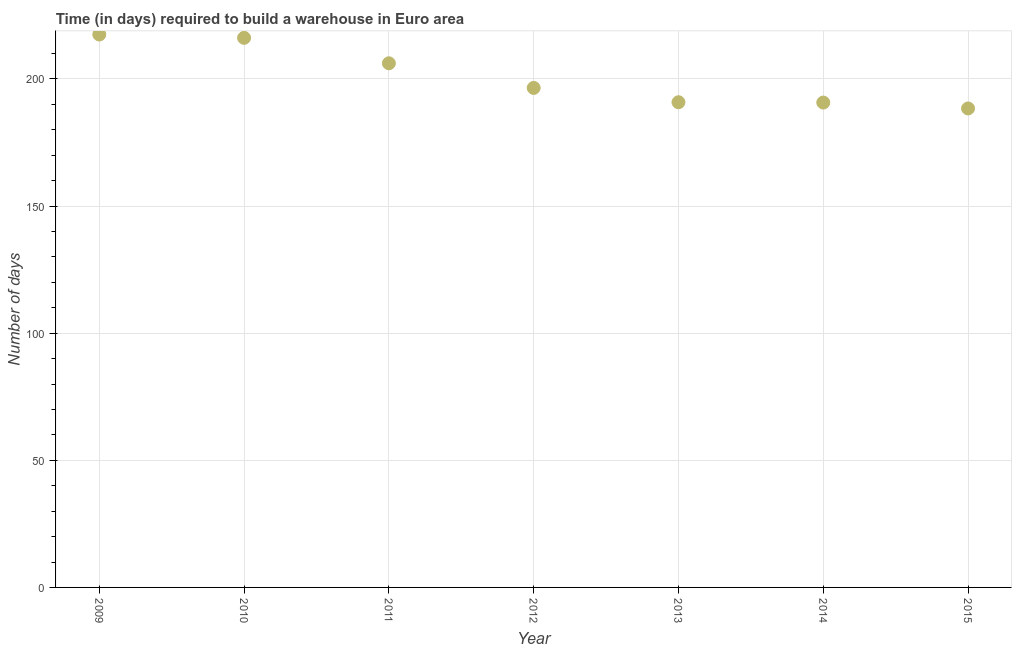What is the time required to build a warehouse in 2010?
Provide a succinct answer. 216.17. Across all years, what is the maximum time required to build a warehouse?
Make the answer very short. 217.47. Across all years, what is the minimum time required to build a warehouse?
Your answer should be compact. 188.39. In which year was the time required to build a warehouse maximum?
Provide a short and direct response. 2009. In which year was the time required to build a warehouse minimum?
Your answer should be compact. 2015. What is the sum of the time required to build a warehouse?
Offer a terse response. 1406.22. What is the difference between the time required to build a warehouse in 2009 and 2011?
Provide a succinct answer. 11.31. What is the average time required to build a warehouse per year?
Offer a terse response. 200.89. What is the median time required to build a warehouse?
Offer a terse response. 196.47. In how many years, is the time required to build a warehouse greater than 70 days?
Your answer should be compact. 7. What is the ratio of the time required to build a warehouse in 2009 to that in 2012?
Offer a very short reply. 1.11. Is the time required to build a warehouse in 2010 less than that in 2014?
Offer a very short reply. No. Is the difference between the time required to build a warehouse in 2011 and 2014 greater than the difference between any two years?
Offer a terse response. No. What is the difference between the highest and the second highest time required to build a warehouse?
Keep it short and to the point. 1.31. Is the sum of the time required to build a warehouse in 2013 and 2015 greater than the maximum time required to build a warehouse across all years?
Provide a short and direct response. Yes. What is the difference between the highest and the lowest time required to build a warehouse?
Offer a very short reply. 29.08. In how many years, is the time required to build a warehouse greater than the average time required to build a warehouse taken over all years?
Your answer should be compact. 3. How many dotlines are there?
Your response must be concise. 1. What is the difference between two consecutive major ticks on the Y-axis?
Your answer should be compact. 50. Are the values on the major ticks of Y-axis written in scientific E-notation?
Offer a terse response. No. Does the graph contain grids?
Make the answer very short. Yes. What is the title of the graph?
Provide a short and direct response. Time (in days) required to build a warehouse in Euro area. What is the label or title of the X-axis?
Provide a short and direct response. Year. What is the label or title of the Y-axis?
Your answer should be compact. Number of days. What is the Number of days in 2009?
Keep it short and to the point. 217.47. What is the Number of days in 2010?
Ensure brevity in your answer.  216.17. What is the Number of days in 2011?
Your response must be concise. 206.16. What is the Number of days in 2012?
Provide a succinct answer. 196.47. What is the Number of days in 2013?
Your answer should be very brief. 190.84. What is the Number of days in 2014?
Your answer should be very brief. 190.71. What is the Number of days in 2015?
Provide a succinct answer. 188.39. What is the difference between the Number of days in 2009 and 2010?
Your response must be concise. 1.31. What is the difference between the Number of days in 2009 and 2011?
Offer a very short reply. 11.31. What is the difference between the Number of days in 2009 and 2012?
Your answer should be compact. 21. What is the difference between the Number of days in 2009 and 2013?
Ensure brevity in your answer.  26.63. What is the difference between the Number of days in 2009 and 2014?
Make the answer very short. 26.76. What is the difference between the Number of days in 2009 and 2015?
Provide a short and direct response. 29.08. What is the difference between the Number of days in 2010 and 2011?
Offer a terse response. 10.01. What is the difference between the Number of days in 2010 and 2012?
Your response must be concise. 19.69. What is the difference between the Number of days in 2010 and 2013?
Provide a short and direct response. 25.32. What is the difference between the Number of days in 2010 and 2014?
Give a very brief answer. 25.46. What is the difference between the Number of days in 2010 and 2015?
Ensure brevity in your answer.  27.77. What is the difference between the Number of days in 2011 and 2012?
Offer a very short reply. 9.68. What is the difference between the Number of days in 2011 and 2013?
Your response must be concise. 15.32. What is the difference between the Number of days in 2011 and 2014?
Ensure brevity in your answer.  15.45. What is the difference between the Number of days in 2011 and 2015?
Your answer should be very brief. 17.76. What is the difference between the Number of days in 2012 and 2013?
Your answer should be compact. 5.63. What is the difference between the Number of days in 2012 and 2014?
Offer a terse response. 5.76. What is the difference between the Number of days in 2012 and 2015?
Your answer should be very brief. 8.08. What is the difference between the Number of days in 2013 and 2014?
Provide a succinct answer. 0.13. What is the difference between the Number of days in 2013 and 2015?
Provide a short and direct response. 2.45. What is the difference between the Number of days in 2014 and 2015?
Ensure brevity in your answer.  2.32. What is the ratio of the Number of days in 2009 to that in 2011?
Offer a very short reply. 1.05. What is the ratio of the Number of days in 2009 to that in 2012?
Give a very brief answer. 1.11. What is the ratio of the Number of days in 2009 to that in 2013?
Offer a very short reply. 1.14. What is the ratio of the Number of days in 2009 to that in 2014?
Offer a terse response. 1.14. What is the ratio of the Number of days in 2009 to that in 2015?
Offer a very short reply. 1.15. What is the ratio of the Number of days in 2010 to that in 2011?
Make the answer very short. 1.05. What is the ratio of the Number of days in 2010 to that in 2013?
Make the answer very short. 1.13. What is the ratio of the Number of days in 2010 to that in 2014?
Your answer should be very brief. 1.13. What is the ratio of the Number of days in 2010 to that in 2015?
Your answer should be very brief. 1.15. What is the ratio of the Number of days in 2011 to that in 2012?
Offer a terse response. 1.05. What is the ratio of the Number of days in 2011 to that in 2013?
Keep it short and to the point. 1.08. What is the ratio of the Number of days in 2011 to that in 2014?
Keep it short and to the point. 1.08. What is the ratio of the Number of days in 2011 to that in 2015?
Your answer should be compact. 1.09. What is the ratio of the Number of days in 2012 to that in 2015?
Provide a short and direct response. 1.04. What is the ratio of the Number of days in 2013 to that in 2015?
Offer a very short reply. 1.01. 